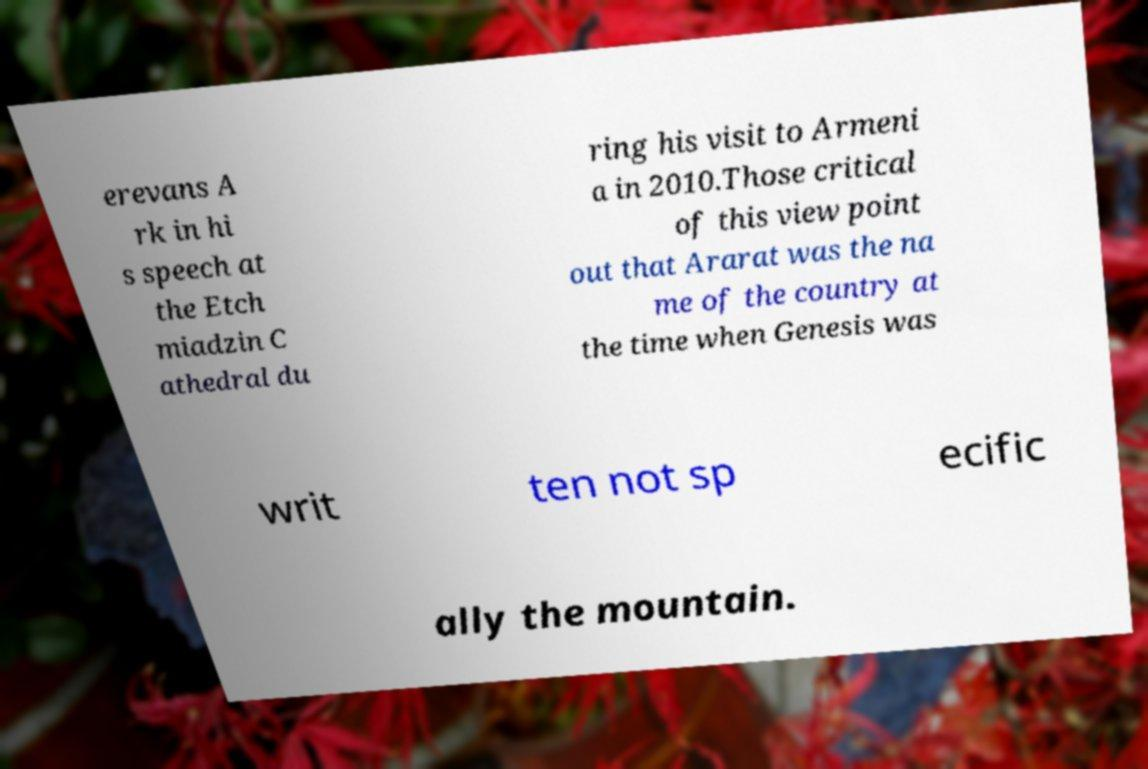There's text embedded in this image that I need extracted. Can you transcribe it verbatim? erevans A rk in hi s speech at the Etch miadzin C athedral du ring his visit to Armeni a in 2010.Those critical of this view point out that Ararat was the na me of the country at the time when Genesis was writ ten not sp ecific ally the mountain. 